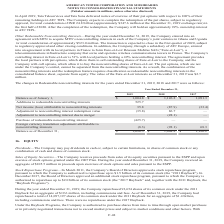According to American Tower Corporation's financial document, What was the value of the Eure-et-Loir interests as of December 31, 2019? According to the financial document, $2.7 million. The relevant text states: "Eure-et-Loir interests as of December 31, 2019 was $2.7 million...." Also, What was the balance as of January 1 in 2019? According to the financial document, $1,004.8 (in millions). The relevant text states: "Balance as of January 1, $ 1,004.8 $ 1,126.2 $ 1,091.3..." Also, What was the Net income (loss) attributable to noncontrolling interests in 2017? According to the financial document, (33.4) (in millions). The relevant text states: "tributable to noncontrolling interests 35.8 (87.9) (33.4)..." Also, can you calculate: What was the change in balance as of January 1 between 2017 and 2018? Based on the calculation: $1,126.2-$1,091.3, the result is 34.9 (in millions). This is based on the information: "Balance as of January 1, $ 1,004.8 $ 1,126.2 $ 1,091.3 Balance as of January 1, $ 1,004.8 $ 1,126.2 $ 1,091.3..." The key data points involved are: 1,091.3, 1,126.2. Also, can you calculate: What was the change in Adjustment to noncontrolling interest redemption value between 2018 and 2019? Based on the calculation: -35.8-86.7, the result is -122.5 (in millions). This is based on the information: "ment to noncontrolling interest redemption value (35.8) 86.7 — o noncontrolling interest redemption value (35.8) 86.7 —..." The key data points involved are: 35.8, 86.7. Also, can you calculate: What was the percentage change in balance as of December 31 between 2018 and 2019? To answer this question, I need to perform calculations using the financial data. The calculation is: ($1,096.5-$1,004.8)/$1,004.8, which equals 9.13 (percentage). This is based on the information: "Balance as of December 31, $ 1,096.5 $ 1,004.8 $ 1,126.2 Balance as of January 1, $ 1,004.8 $ 1,126.2 $ 1,091.3..." The key data points involved are: 1,004.8, 1,096.5. 